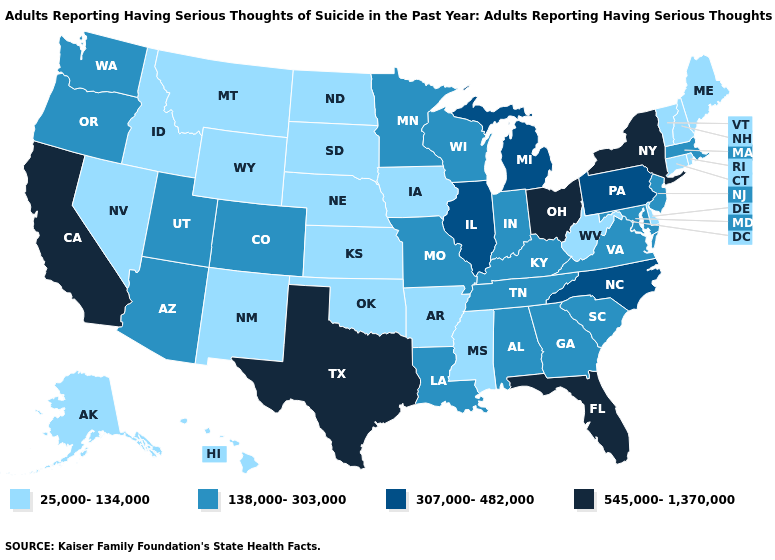Among the states that border South Dakota , does North Dakota have the highest value?
Write a very short answer. No. What is the value of Illinois?
Keep it brief. 307,000-482,000. What is the lowest value in the USA?
Give a very brief answer. 25,000-134,000. Does Colorado have the lowest value in the USA?
Short answer required. No. What is the value of Utah?
Quick response, please. 138,000-303,000. What is the value of Nebraska?
Short answer required. 25,000-134,000. Is the legend a continuous bar?
Short answer required. No. Does Ohio have the lowest value in the USA?
Short answer required. No. Does New Jersey have the lowest value in the Northeast?
Answer briefly. No. What is the value of Alaska?
Short answer required. 25,000-134,000. What is the value of Louisiana?
Keep it brief. 138,000-303,000. What is the value of Michigan?
Answer briefly. 307,000-482,000. Does Florida have the highest value in the USA?
Give a very brief answer. Yes. How many symbols are there in the legend?
Keep it brief. 4. Is the legend a continuous bar?
Be succinct. No. 